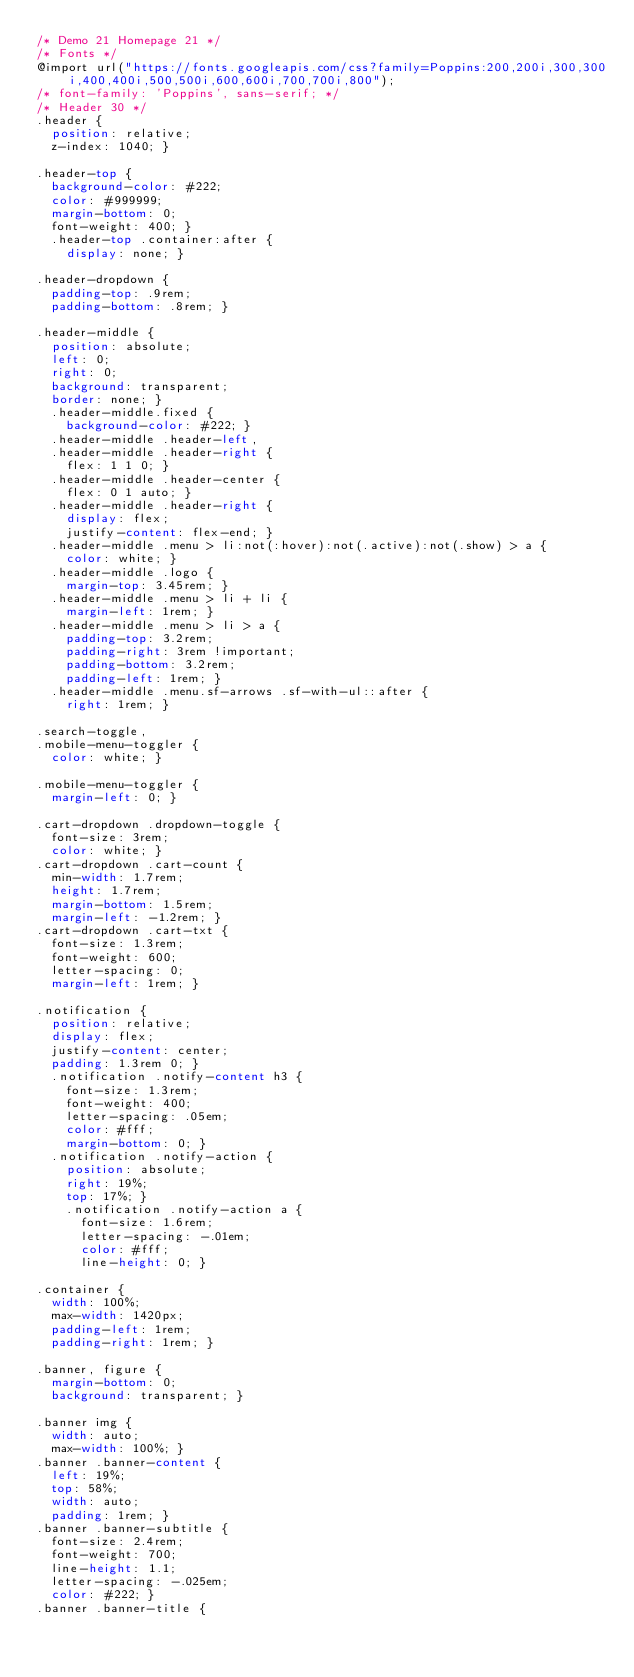<code> <loc_0><loc_0><loc_500><loc_500><_CSS_>/* Demo 21 Homepage 21 */
/* Fonts */
@import url("https://fonts.googleapis.com/css?family=Poppins:200,200i,300,300i,400,400i,500,500i,600,600i,700,700i,800");
/* font-family: 'Poppins', sans-serif; */
/* Header 30 */
.header {
  position: relative;
  z-index: 1040; }

.header-top {
  background-color: #222;
  color: #999999;
  margin-bottom: 0;
  font-weight: 400; }
  .header-top .container:after {
    display: none; }

.header-dropdown {
  padding-top: .9rem;
  padding-bottom: .8rem; }

.header-middle {
  position: absolute;
  left: 0;
  right: 0;
  background: transparent;
  border: none; }
  .header-middle.fixed {
    background-color: #222; }
  .header-middle .header-left,
  .header-middle .header-right {
    flex: 1 1 0; }
  .header-middle .header-center {
    flex: 0 1 auto; }
  .header-middle .header-right {
    display: flex;
    justify-content: flex-end; }
  .header-middle .menu > li:not(:hover):not(.active):not(.show) > a {
    color: white; }
  .header-middle .logo {
    margin-top: 3.45rem; }
  .header-middle .menu > li + li {
    margin-left: 1rem; }
  .header-middle .menu > li > a {
    padding-top: 3.2rem;
    padding-right: 3rem !important;
    padding-bottom: 3.2rem;
    padding-left: 1rem; }
  .header-middle .menu.sf-arrows .sf-with-ul::after {
    right: 1rem; }

.search-toggle,
.mobile-menu-toggler {
  color: white; }

.mobile-menu-toggler {
  margin-left: 0; }

.cart-dropdown .dropdown-toggle {
  font-size: 3rem;
  color: white; }
.cart-dropdown .cart-count {
  min-width: 1.7rem;
  height: 1.7rem;
  margin-bottom: 1.5rem;
  margin-left: -1.2rem; }
.cart-dropdown .cart-txt {
  font-size: 1.3rem;
  font-weight: 600;
  letter-spacing: 0;
  margin-left: 1rem; }

.notification {
  position: relative;
  display: flex;
  justify-content: center;
  padding: 1.3rem 0; }
  .notification .notify-content h3 {
    font-size: 1.3rem;
    font-weight: 400;
    letter-spacing: .05em;
    color: #fff;
    margin-bottom: 0; }
  .notification .notify-action {
    position: absolute;
    right: 19%;
    top: 17%; }
    .notification .notify-action a {
      font-size: 1.6rem;
      letter-spacing: -.01em;
      color: #fff;
      line-height: 0; }

.container {
  width: 100%;
  max-width: 1420px;
  padding-left: 1rem;
  padding-right: 1rem; }

.banner, figure {
  margin-bottom: 0;
  background: transparent; }

.banner img {
  width: auto;
  max-width: 100%; }
.banner .banner-content {
  left: 19%;
  top: 58%;
  width: auto;
  padding: 1rem; }
.banner .banner-subtitle {
  font-size: 2.4rem;
  font-weight: 700;
  line-height: 1.1;
  letter-spacing: -.025em;
  color: #222; }
.banner .banner-title {</code> 